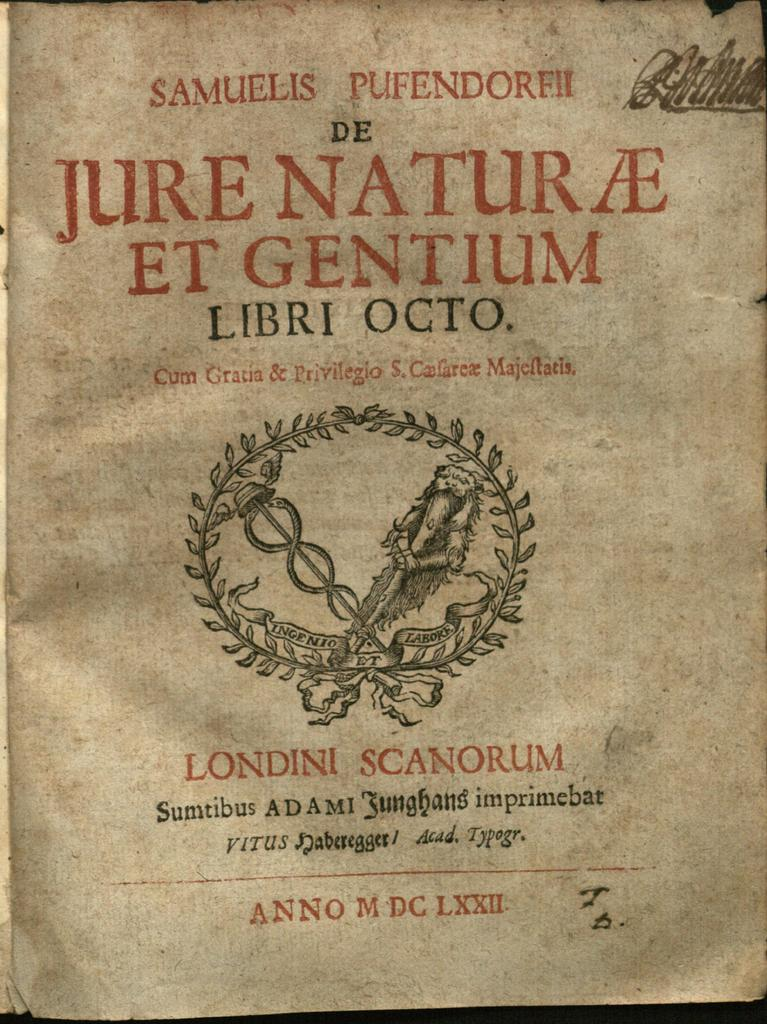<image>
Offer a succinct explanation of the picture presented. A seal appears above the words Londini Scanorum. 